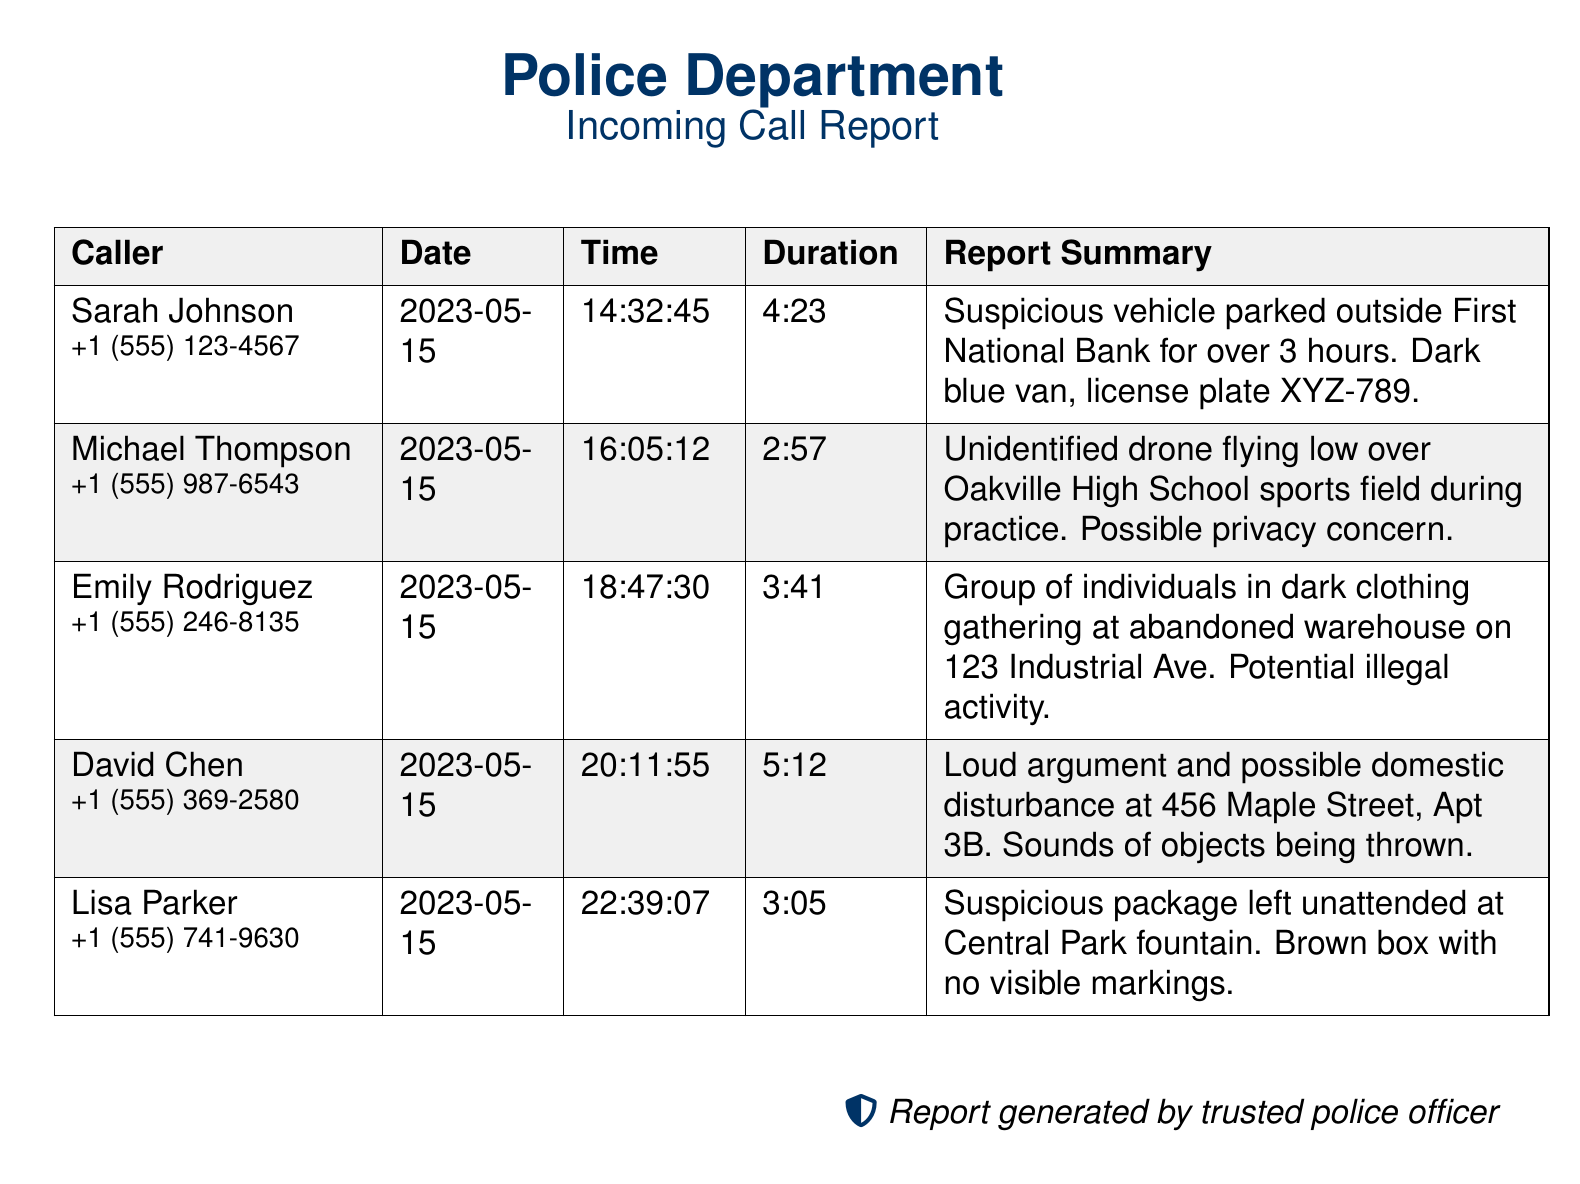What is the name of the caller who reported a suspicious vehicle? The report indicates Sarah Johnson called about a suspicious vehicle outside the First National Bank.
Answer: Sarah Johnson What time did Michael Thompson make his report? The report notes Michael Thompson's call was made at 16:05:12.
Answer: 16:05:12 What was the duration of the call from David Chen? The duration of David Chen's call is specified as 5 minutes and 12 seconds.
Answer: 5:12 How many individuals were reported gathering at the abandoned warehouse? The report states a group of individuals in dark clothing was gathering but does not specify a number.
Answer: Group What type of disturbance was reported at 456 Maple Street? The report mentions a loud argument and possible domestic disturbance being heard at that location.
Answer: Domestic disturbance What color is the suspicious vehicle reported by Sarah Johnson? The report described the suspicious vehicle as a dark blue van.
Answer: Dark blue When was the last call reported? The last call recorded was made on 2023-05-15.
Answer: 2023-05-15 What was left unattended at Central Park fountain? The report mentions a suspicious package was left unattended at the fountain.
Answer: Suspicious package What is the license plate of the vehicle mentioned in the first report? The report lists the license plate of the vehicle as XYZ-789.
Answer: XYZ-789 